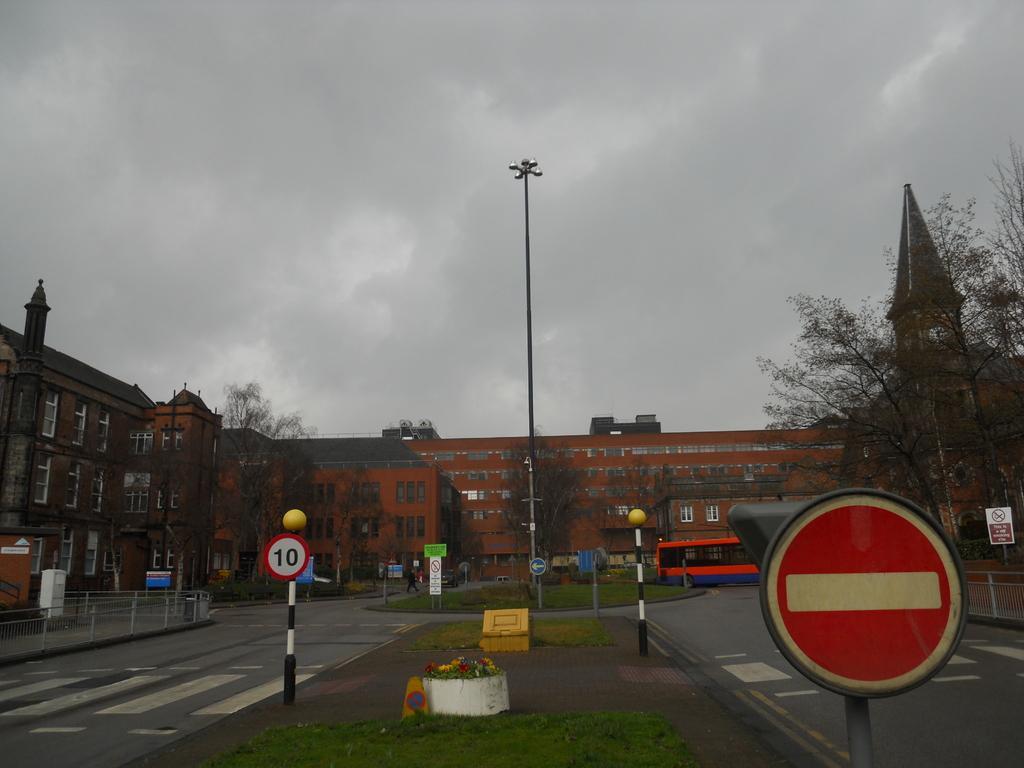Please provide a concise description of this image. In this image we can see a bus parked on the ground and a person walking. In the center of the image we can see a car, building with windows, poles and grass. In the foreground of the image we can see some flowers on the plants. On the left side of the image we can see railings and some objects placed on the ground. On the right side of the image we can see trees. At the top of the image we can see the sky. 